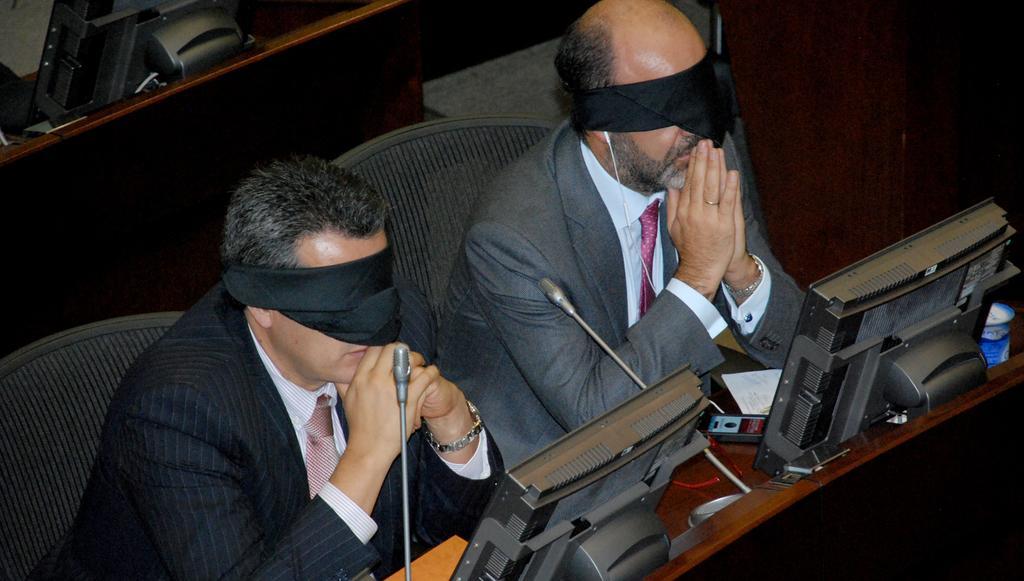How would you summarize this image in a sentence or two? In this image we can see two men are sitting on chairs. They are wearing suits and black color cloth on their eyes. In front of them, we can see monitors, mics, paper and an object. In the top left of the image, we can see a monitor. 